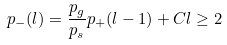Convert formula to latex. <formula><loc_0><loc_0><loc_500><loc_500>p _ { - } ( l ) = \frac { p _ { g } } { p _ { s } } p _ { + } ( l - 1 ) + C l \geq 2</formula> 